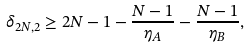<formula> <loc_0><loc_0><loc_500><loc_500>\delta _ { 2 N , 2 } \geq 2 N - 1 - \frac { N - 1 } { \eta _ { A } } - \frac { N - 1 } { \eta _ { B } } ,</formula> 